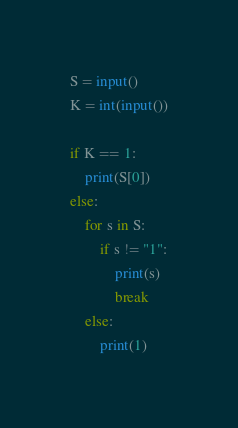<code> <loc_0><loc_0><loc_500><loc_500><_Python_>S = input()
K = int(input())

if K == 1:
    print(S[0])
else:
    for s in S:
        if s != "1":
            print(s)
            break
    else:
        print(1)
</code> 